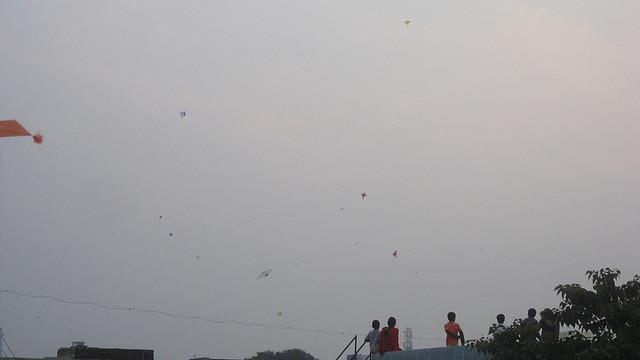How many people are standing?
Answer briefly. 6. Do you think this photo was taken near a body of water?
Be succinct. Yes. What flag is waving?
Keep it brief. None. Are people moving to a new place?
Short answer required. No. Are there lights on in the picture?
Quick response, please. No. What kind of weather is it?
Quick response, please. Cloudy. How many people are in the picture?
Concise answer only. 6. How many colors are the kite?
Quick response, please. 1. Is there a White House in the background?
Answer briefly. No. What is in the air?
Short answer required. Kites. What's the weather like?
Write a very short answer. Cloudy. 